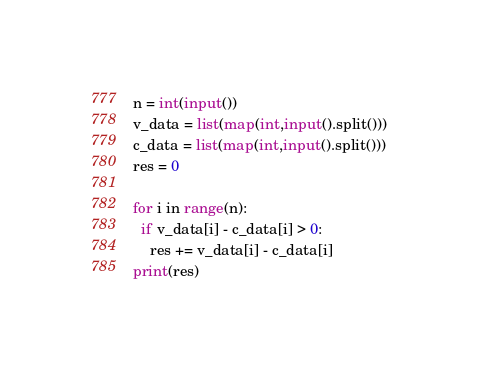<code> <loc_0><loc_0><loc_500><loc_500><_Python_>n = int(input())
v_data = list(map(int,input().split()))
c_data = list(map(int,input().split()))
res = 0

for i in range(n):
  if v_data[i] - c_data[i] > 0:
    res += v_data[i] - c_data[i]
print(res)</code> 